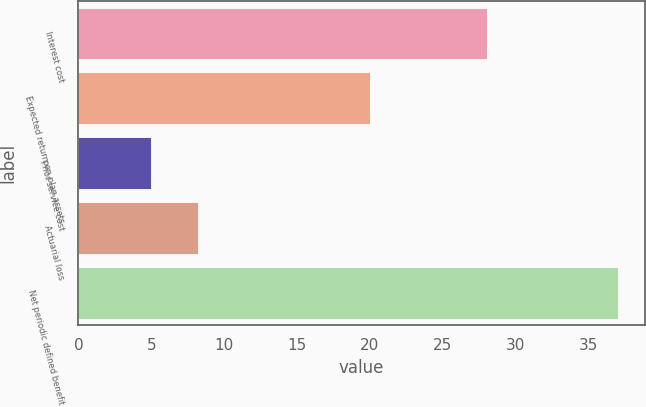<chart> <loc_0><loc_0><loc_500><loc_500><bar_chart><fcel>Interest cost<fcel>Expected return on plan assets<fcel>Prior service cost<fcel>Actuarial loss<fcel>Net periodic defined benefit<nl><fcel>28<fcel>20<fcel>5<fcel>8.2<fcel>37<nl></chart> 